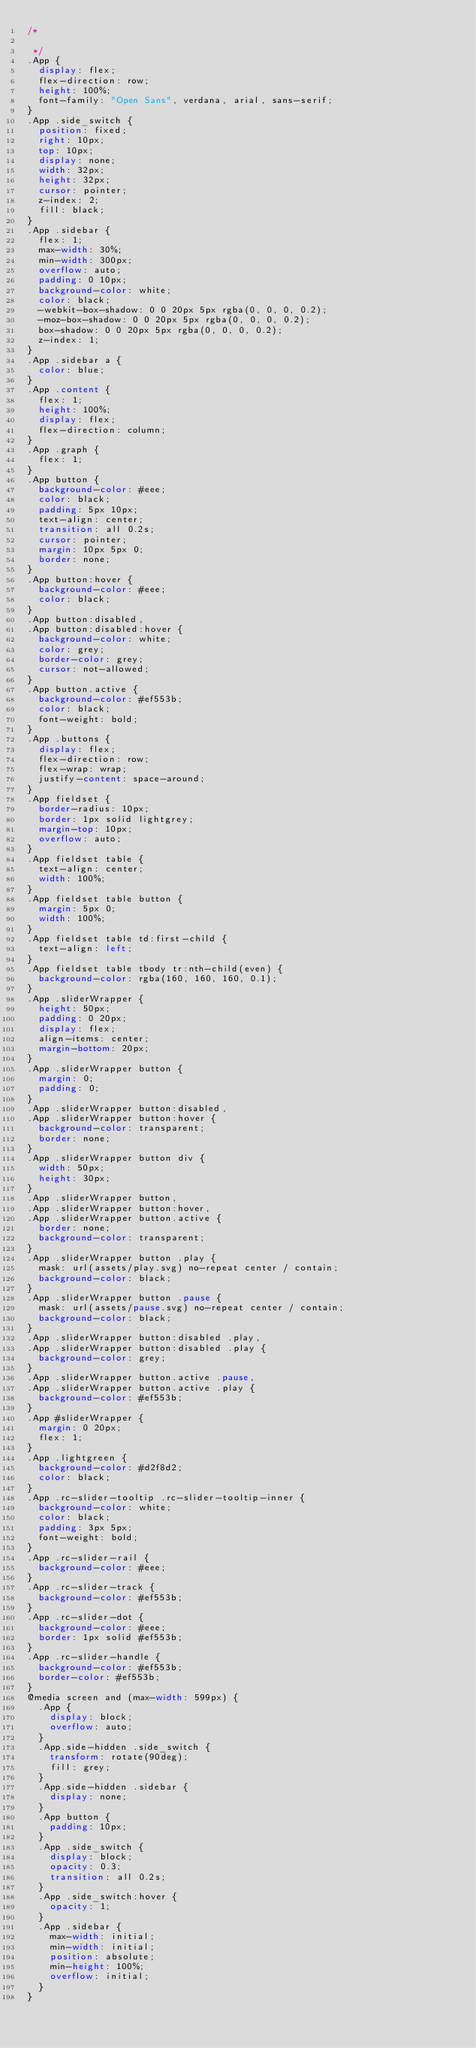Convert code to text. <code><loc_0><loc_0><loc_500><loc_500><_CSS_>/*

 */
.App {
  display: flex;
  flex-direction: row;
  height: 100%;
  font-family: "Open Sans", verdana, arial, sans-serif;
}
.App .side_switch {
  position: fixed;
  right: 10px;
  top: 10px;
  display: none;
  width: 32px;
  height: 32px;
  cursor: pointer;
  z-index: 2;
  fill: black;
}
.App .sidebar {
  flex: 1;
  max-width: 30%;
  min-width: 300px;
  overflow: auto;
  padding: 0 10px;
  background-color: white;
  color: black;
  -webkit-box-shadow: 0 0 20px 5px rgba(0, 0, 0, 0.2);
  -moz-box-shadow: 0 0 20px 5px rgba(0, 0, 0, 0.2);
  box-shadow: 0 0 20px 5px rgba(0, 0, 0, 0.2);
  z-index: 1;
}
.App .sidebar a {
  color: blue;
}
.App .content {
  flex: 1;
  height: 100%;
  display: flex;
  flex-direction: column;
}
.App .graph {
  flex: 1;
}
.App button {
  background-color: #eee;
  color: black;
  padding: 5px 10px;
  text-align: center;
  transition: all 0.2s;
  cursor: pointer;
  margin: 10px 5px 0;
  border: none;
}
.App button:hover {
  background-color: #eee;
  color: black;
}
.App button:disabled,
.App button:disabled:hover {
  background-color: white;
  color: grey;
  border-color: grey;
  cursor: not-allowed;
}
.App button.active {
  background-color: #ef553b;
  color: black;
  font-weight: bold;
}
.App .buttons {
  display: flex;
  flex-direction: row;
  flex-wrap: wrap;
  justify-content: space-around;
}
.App fieldset {
  border-radius: 10px;
  border: 1px solid lightgrey;
  margin-top: 10px;
  overflow: auto;
}
.App fieldset table {
  text-align: center;
  width: 100%;
}
.App fieldset table button {
  margin: 5px 0;
  width: 100%;
}
.App fieldset table td:first-child {
  text-align: left;
}
.App fieldset table tbody tr:nth-child(even) {
  background-color: rgba(160, 160, 160, 0.1);
}
.App .sliderWrapper {
  height: 50px;
  padding: 0 20px;
  display: flex;
  align-items: center;
  margin-bottom: 20px;
}
.App .sliderWrapper button {
  margin: 0;
  padding: 0;
}
.App .sliderWrapper button:disabled,
.App .sliderWrapper button:hover {
  background-color: transparent;
  border: none;
}
.App .sliderWrapper button div {
  width: 50px;
  height: 30px;
}
.App .sliderWrapper button,
.App .sliderWrapper button:hover,
.App .sliderWrapper button.active {
  border: none;
  background-color: transparent;
}
.App .sliderWrapper button .play {
  mask: url(assets/play.svg) no-repeat center / contain;
  background-color: black;
}
.App .sliderWrapper button .pause {
  mask: url(assets/pause.svg) no-repeat center / contain;
  background-color: black;
}
.App .sliderWrapper button:disabled .play,
.App .sliderWrapper button:disabled .play {
  background-color: grey;
}
.App .sliderWrapper button.active .pause,
.App .sliderWrapper button.active .play {
  background-color: #ef553b;
}
.App #sliderWrapper {
  margin: 0 20px;
  flex: 1;
}
.App .lightgreen {
  background-color: #d2f8d2;
  color: black;
}
.App .rc-slider-tooltip .rc-slider-tooltip-inner {
  background-color: white;
  color: black;
  padding: 3px 5px;
  font-weight: bold;
}
.App .rc-slider-rail {
  background-color: #eee;
}
.App .rc-slider-track {
  background-color: #ef553b;
}
.App .rc-slider-dot {
  background-color: #eee;
  border: 1px solid #ef553b;
}
.App .rc-slider-handle {
  background-color: #ef553b;
  border-color: #ef553b;
}
@media screen and (max-width: 599px) {
  .App {
    display: block;
    overflow: auto;
  }
  .App.side-hidden .side_switch {
    transform: rotate(90deg);
    fill: grey;
  }
  .App.side-hidden .sidebar {
    display: none;
  }
  .App button {
    padding: 10px;
  }
  .App .side_switch {
    display: block;
    opacity: 0.3;
    transition: all 0.2s;
  }
  .App .side_switch:hover {
    opacity: 1;
  }
  .App .sidebar {
    max-width: initial;
    min-width: initial;
    position: absolute;
    min-height: 100%;
    overflow: initial;
  }
}
</code> 